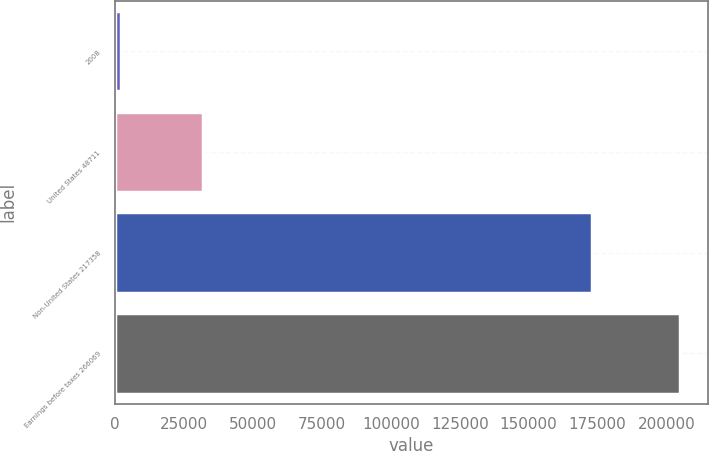Convert chart. <chart><loc_0><loc_0><loc_500><loc_500><bar_chart><fcel>2008<fcel>United States 48711<fcel>Non-United States 217358<fcel>Earnings before taxes 266069<nl><fcel>2006<fcel>31889<fcel>172958<fcel>204847<nl></chart> 